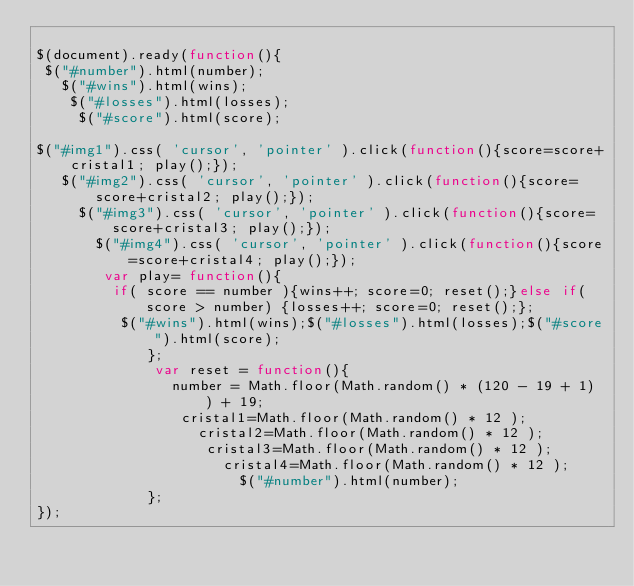<code> <loc_0><loc_0><loc_500><loc_500><_JavaScript_>
$(document).ready(function(){
 $("#number").html(number);
   $("#wins").html(wins);
    $("#losses").html(losses);
     $("#score").html(score);

$("#img1").css( 'cursor', 'pointer' ).click(function(){score=score+cristal1; play();});
   $("#img2").css( 'cursor', 'pointer' ).click(function(){score=score+cristal2; play();});
     $("#img3").css( 'cursor', 'pointer' ).click(function(){score=score+cristal3; play();});
       $("#img4").css( 'cursor', 'pointer' ).click(function(){score=score+cristal4; play();});
        var play= function(){
         if( score == number ){wins++; score=0; reset();}else if(score > number) {losses++; score=0; reset();};
          $("#wins").html(wins);$("#losses").html(losses);$("#score").html(score);
             };
              var reset = function(){
                number = Math.floor(Math.random() * (120 - 19 + 1) ) + 19;
                 cristal1=Math.floor(Math.random() * 12 );
                   cristal2=Math.floor(Math.random() * 12 );
                    cristal3=Math.floor(Math.random() * 12 );
                      cristal4=Math.floor(Math.random() * 12 );
                        $("#number").html(number);
             };
});
</code> 